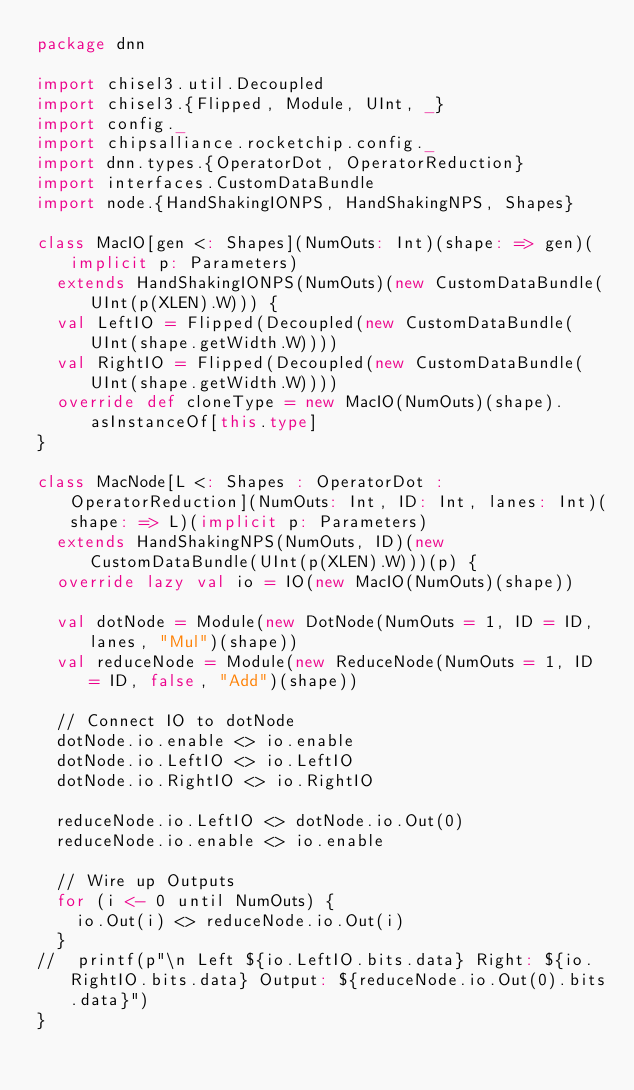<code> <loc_0><loc_0><loc_500><loc_500><_Scala_>package dnn

import chisel3.util.Decoupled
import chisel3.{Flipped, Module, UInt, _}
import config._
import chipsalliance.rocketchip.config._
import dnn.types.{OperatorDot, OperatorReduction}
import interfaces.CustomDataBundle
import node.{HandShakingIONPS, HandShakingNPS, Shapes}

class MacIO[gen <: Shapes](NumOuts: Int)(shape: => gen)(implicit p: Parameters)
  extends HandShakingIONPS(NumOuts)(new CustomDataBundle(UInt(p(XLEN).W))) {
  val LeftIO = Flipped(Decoupled(new CustomDataBundle(UInt(shape.getWidth.W))))
  val RightIO = Flipped(Decoupled(new CustomDataBundle(UInt(shape.getWidth.W))))
  override def cloneType = new MacIO(NumOuts)(shape).asInstanceOf[this.type]
}

class MacNode[L <: Shapes : OperatorDot : OperatorReduction](NumOuts: Int, ID: Int, lanes: Int)(shape: => L)(implicit p: Parameters)
  extends HandShakingNPS(NumOuts, ID)(new CustomDataBundle(UInt(p(XLEN).W)))(p) {
  override lazy val io = IO(new MacIO(NumOuts)(shape))

  val dotNode = Module(new DotNode(NumOuts = 1, ID = ID, lanes, "Mul")(shape))
  val reduceNode = Module(new ReduceNode(NumOuts = 1, ID = ID, false, "Add")(shape))

  // Connect IO to dotNode
  dotNode.io.enable <> io.enable
  dotNode.io.LeftIO <> io.LeftIO
  dotNode.io.RightIO <> io.RightIO

  reduceNode.io.LeftIO <> dotNode.io.Out(0)
  reduceNode.io.enable <> io.enable

  // Wire up Outputs
  for (i <- 0 until NumOuts) {
    io.Out(i) <> reduceNode.io.Out(i)
  }
//  printf(p"\n Left ${io.LeftIO.bits.data} Right: ${io.RightIO.bits.data} Output: ${reduceNode.io.Out(0).bits.data}")
}


</code> 